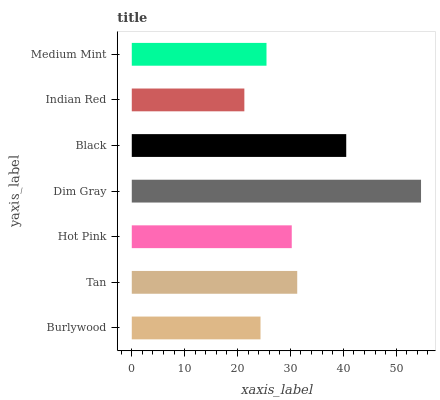Is Indian Red the minimum?
Answer yes or no. Yes. Is Dim Gray the maximum?
Answer yes or no. Yes. Is Tan the minimum?
Answer yes or no. No. Is Tan the maximum?
Answer yes or no. No. Is Tan greater than Burlywood?
Answer yes or no. Yes. Is Burlywood less than Tan?
Answer yes or no. Yes. Is Burlywood greater than Tan?
Answer yes or no. No. Is Tan less than Burlywood?
Answer yes or no. No. Is Hot Pink the high median?
Answer yes or no. Yes. Is Hot Pink the low median?
Answer yes or no. Yes. Is Burlywood the high median?
Answer yes or no. No. Is Tan the low median?
Answer yes or no. No. 